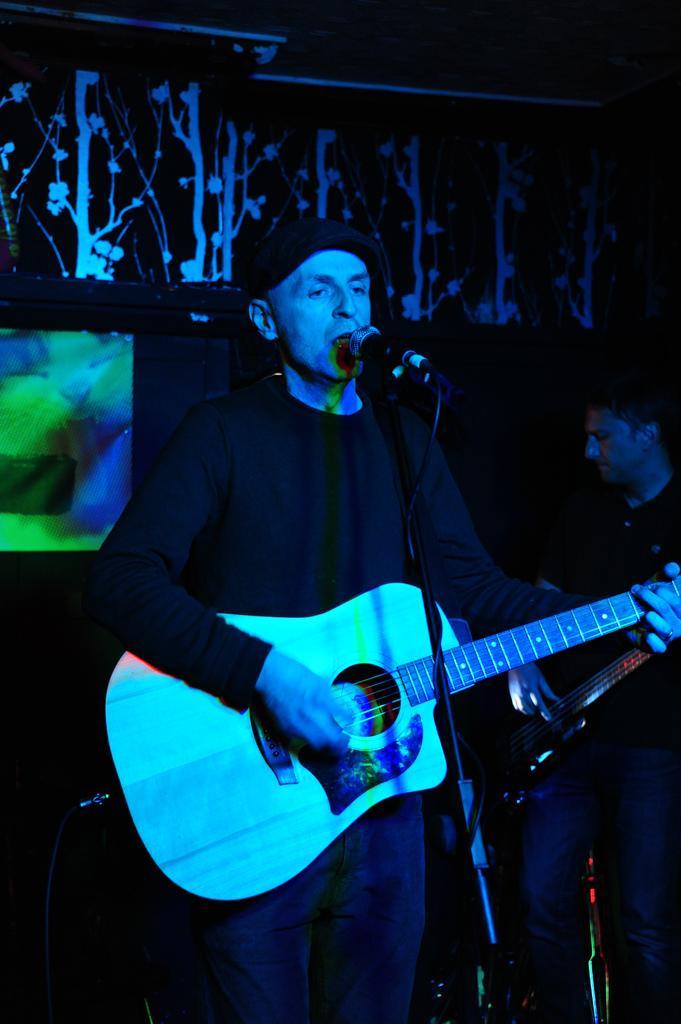How would you summarize this image in a sentence or two? A man is singing with a mic in front of him. He wears dark color clothes and a cap. 